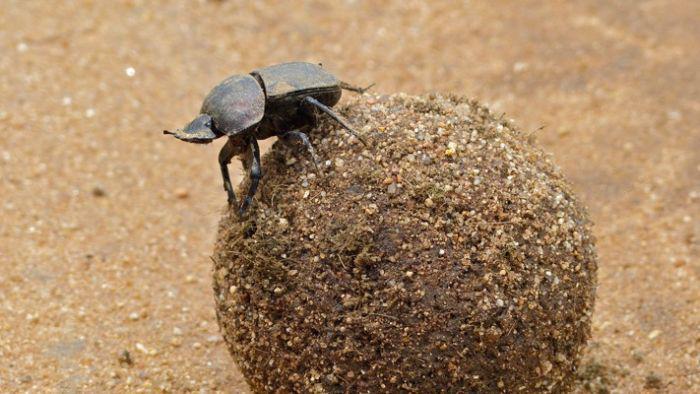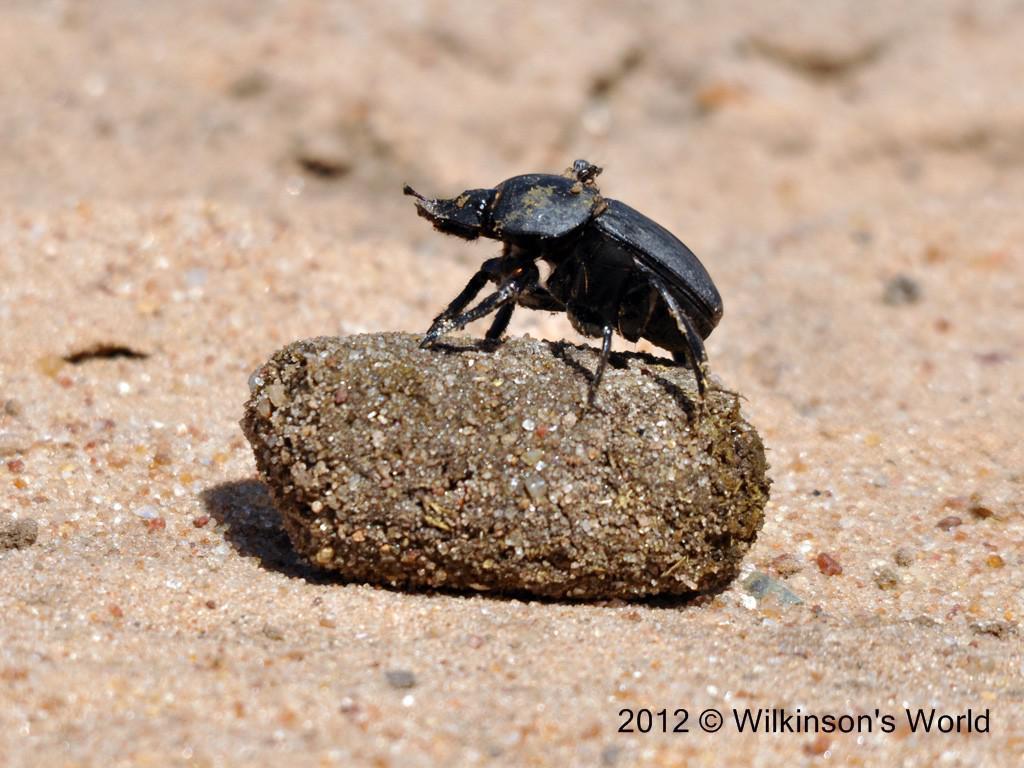The first image is the image on the left, the second image is the image on the right. Analyze the images presented: Is the assertion "Every image has a single beetle and a single dungball." valid? Answer yes or no. Yes. The first image is the image on the left, the second image is the image on the right. For the images shown, is this caption "One image contains two beetles and a single brown ball." true? Answer yes or no. No. 